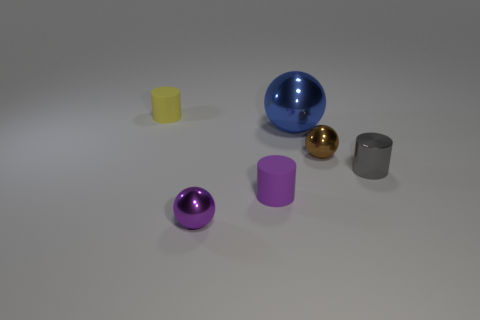The gray metallic cylinder has what size?
Provide a succinct answer. Small. Do the purple shiny object and the blue metal object have the same size?
Your response must be concise. No. What number of things are either tiny objects that are to the left of the purple matte cylinder or small shiny balls that are to the left of the small brown object?
Ensure brevity in your answer.  2. There is a sphere left of the small matte cylinder that is in front of the yellow cylinder; how many tiny matte things are left of it?
Offer a very short reply. 1. What is the size of the cylinder on the right side of the brown object?
Offer a very short reply. Small. What number of other purple cylinders have the same size as the shiny cylinder?
Give a very brief answer. 1. There is a purple rubber object; is it the same size as the matte cylinder behind the big metal object?
Offer a very short reply. Yes. What number of objects are brown balls or small yellow matte things?
Your answer should be very brief. 2. How many large things are the same color as the large ball?
Offer a very short reply. 0. There is a brown object that is the same size as the gray cylinder; what is its shape?
Your response must be concise. Sphere. 